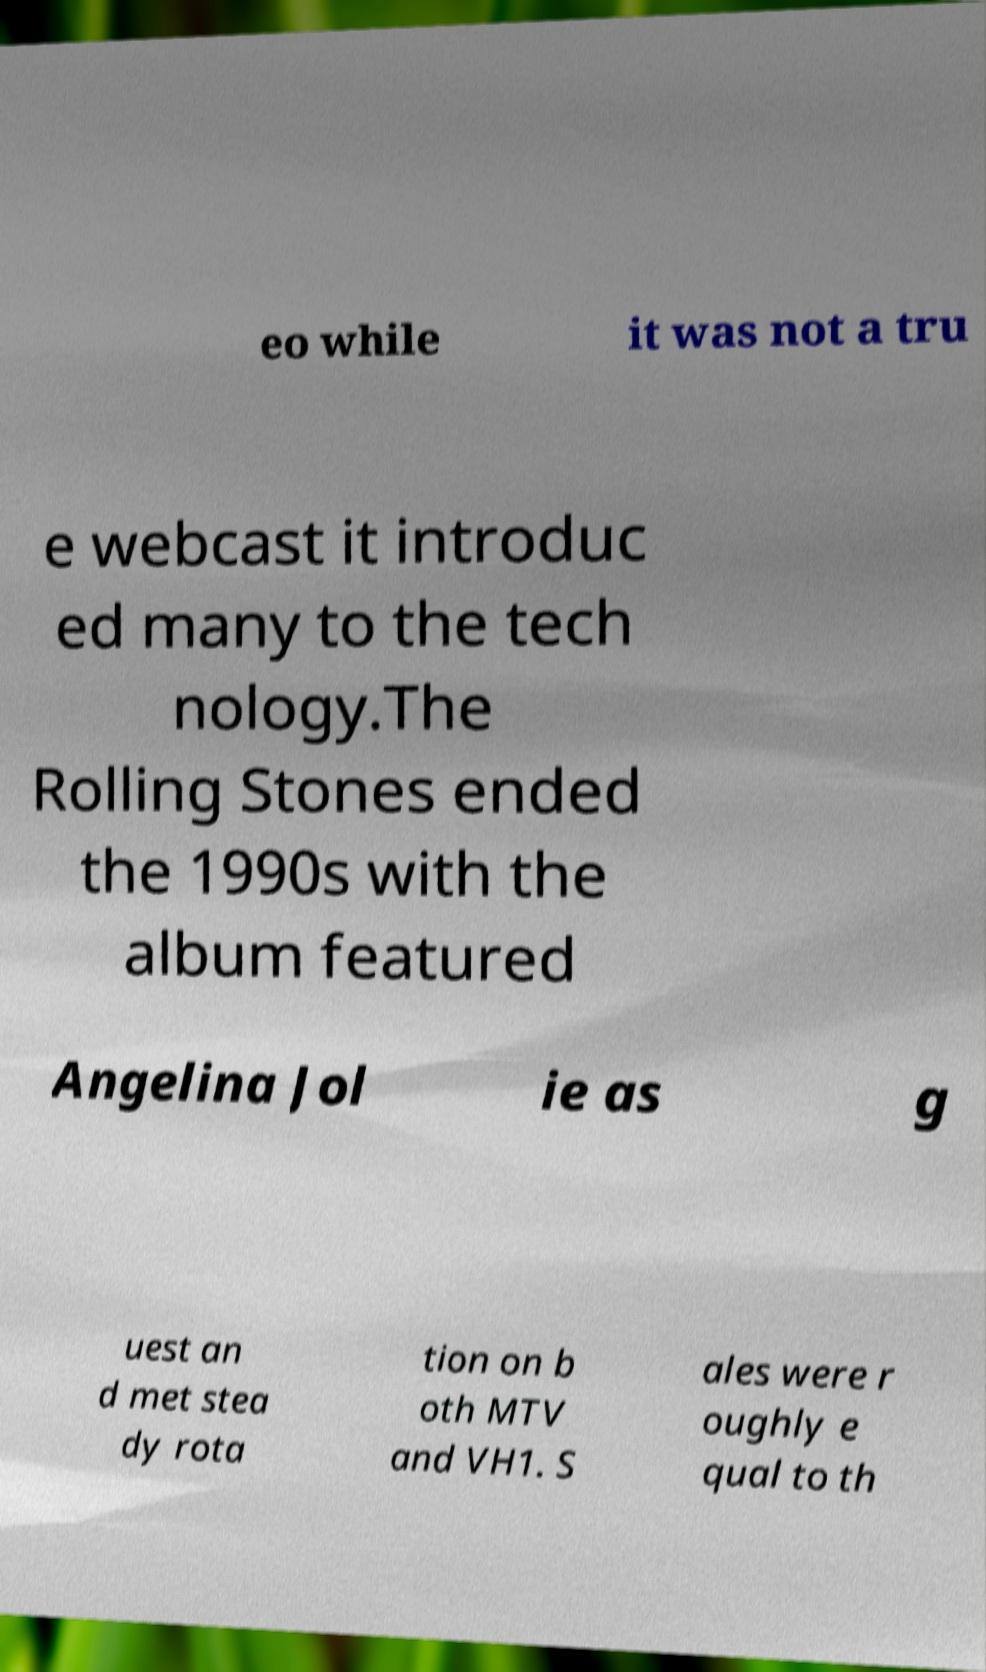Can you read and provide the text displayed in the image?This photo seems to have some interesting text. Can you extract and type it out for me? eo while it was not a tru e webcast it introduc ed many to the tech nology.The Rolling Stones ended the 1990s with the album featured Angelina Jol ie as g uest an d met stea dy rota tion on b oth MTV and VH1. S ales were r oughly e qual to th 